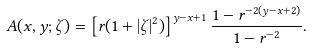<formula> <loc_0><loc_0><loc_500><loc_500>A ( x , y ; \zeta ) = \left [ r ( 1 + | \zeta | ^ { 2 } ) \right ] ^ { y - x + 1 } \frac { 1 - r ^ { - 2 ( y - x + 2 ) } } { 1 - r ^ { - 2 } } .</formula> 